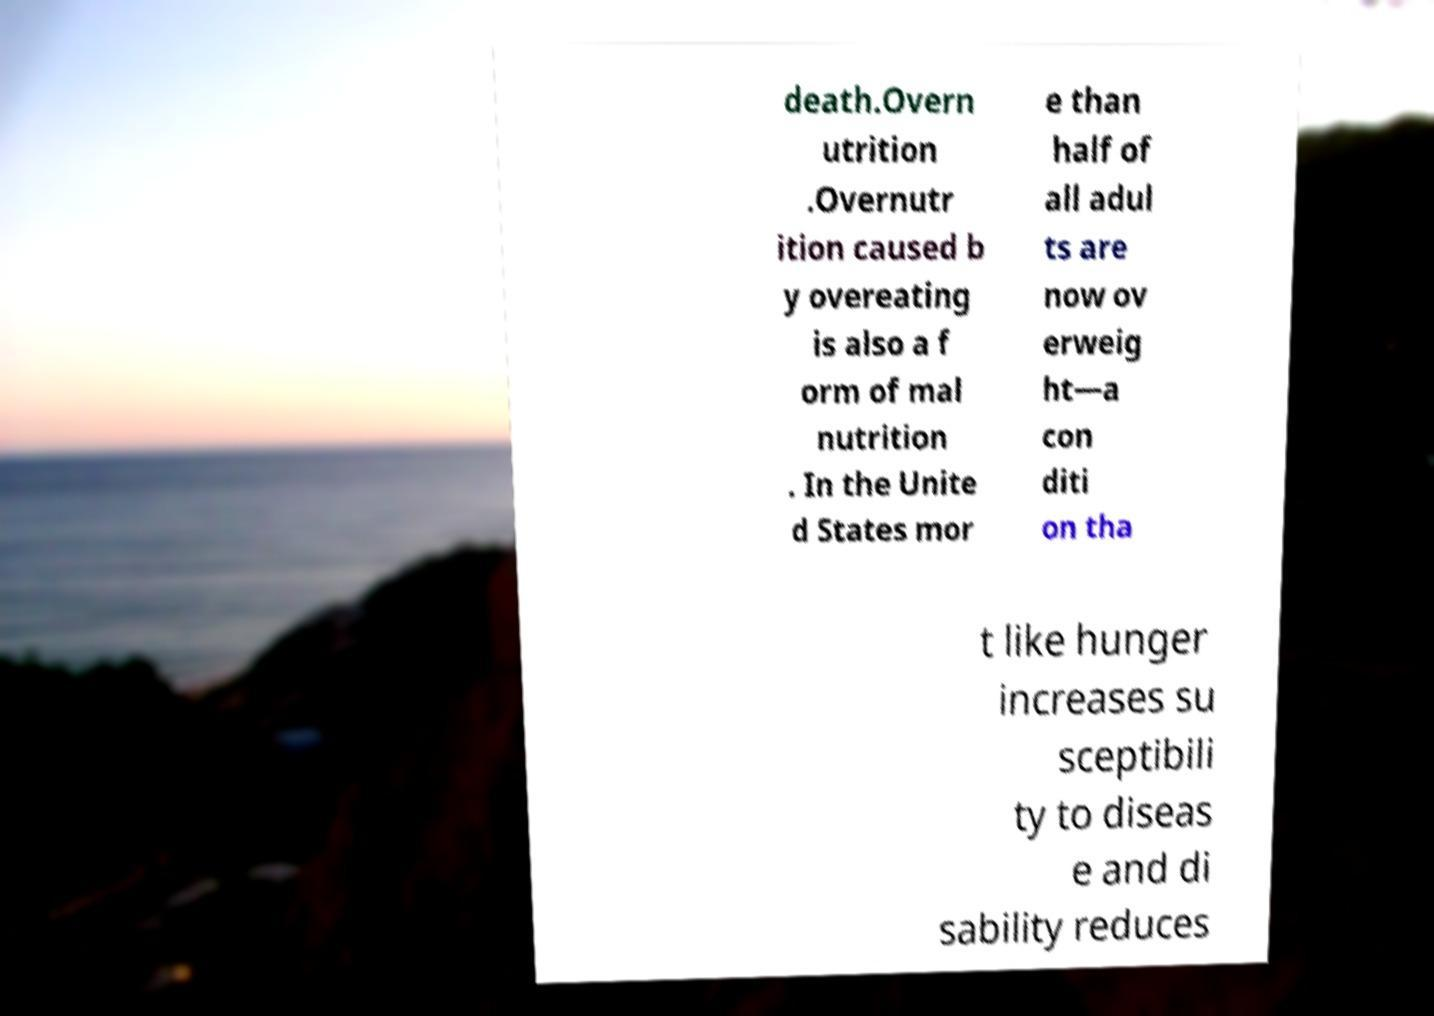Can you accurately transcribe the text from the provided image for me? death.Overn utrition .Overnutr ition caused b y overeating is also a f orm of mal nutrition . In the Unite d States mor e than half of all adul ts are now ov erweig ht—a con diti on tha t like hunger increases su sceptibili ty to diseas e and di sability reduces 